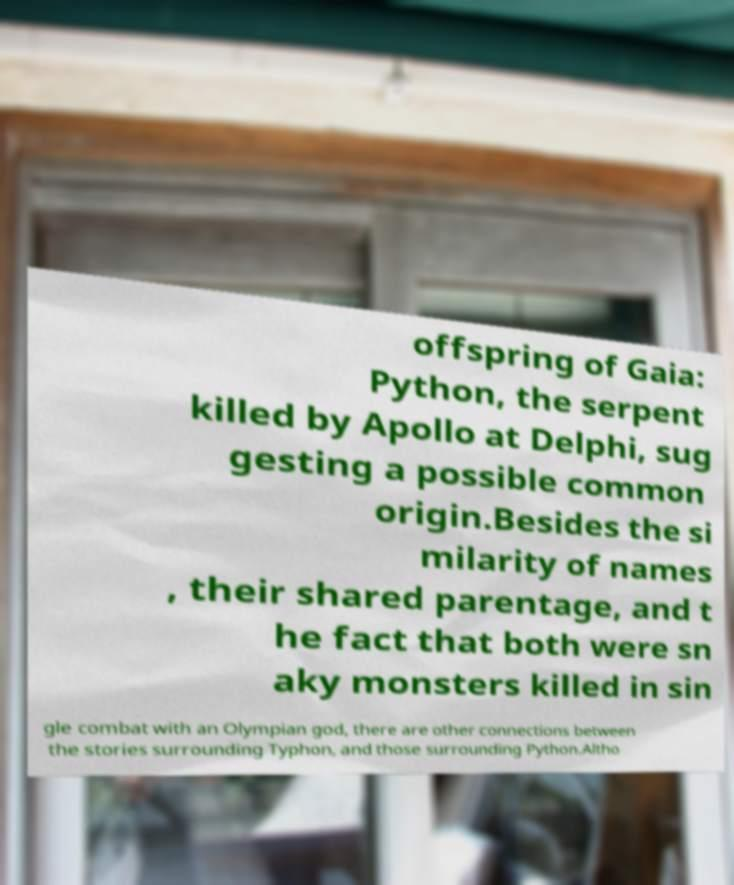Could you extract and type out the text from this image? offspring of Gaia: Python, the serpent killed by Apollo at Delphi, sug gesting a possible common origin.Besides the si milarity of names , their shared parentage, and t he fact that both were sn aky monsters killed in sin gle combat with an Olympian god, there are other connections between the stories surrounding Typhon, and those surrounding Python.Altho 